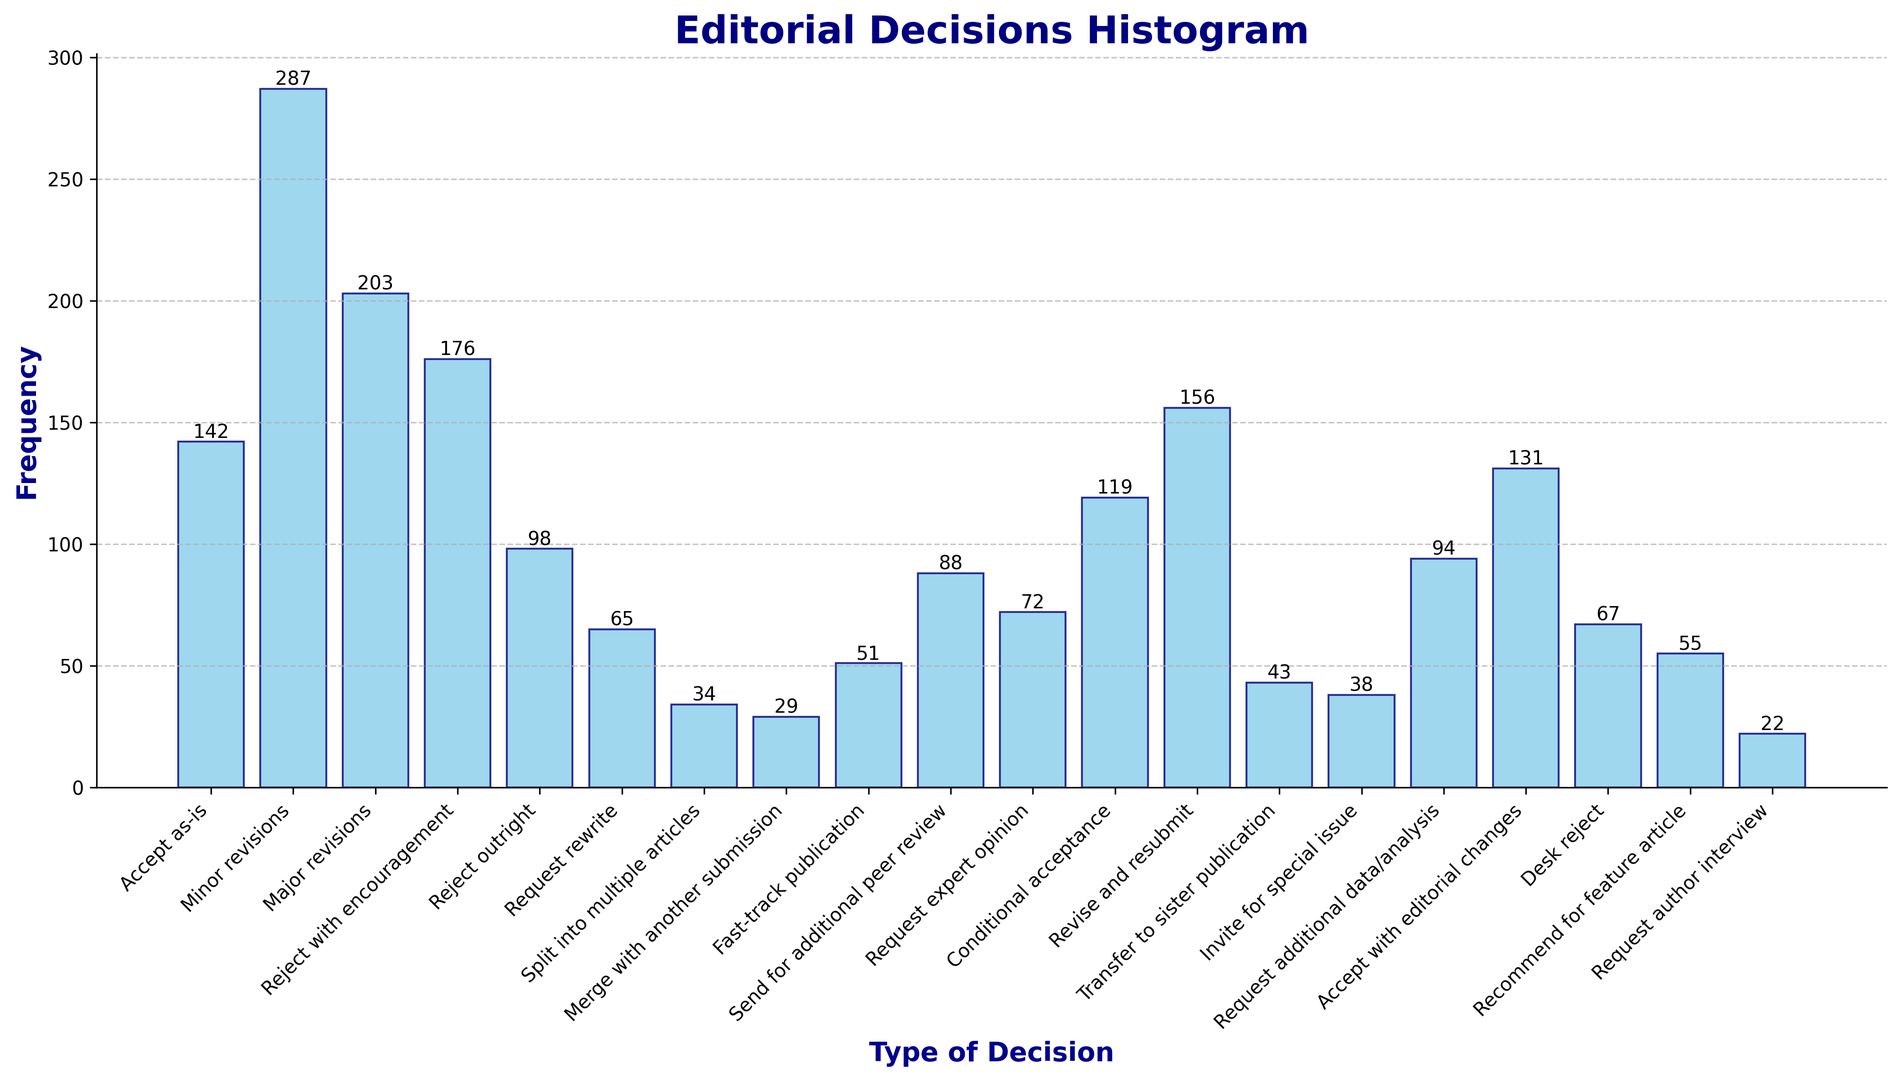What is the most frequent type of editorial decision? The histogram shows bars representing frequencies of each decision type. The tallest bar indicates the most frequent decision. The "Minor revisions" bar is the tallest.
Answer: Minor revisions How many total decisions resulted in either "Accept as-is" or "Desk reject"? Identify the frequencies for "Accept as-is" (142) and "Desk reject" (67), then sum them: 142 + 67 = 209.
Answer: 209 Which decision type has the smallest frequency? The histogram shows bars' heights corresponding to frequencies. The shortest bar represents the least frequent decision, which is "Request author interview" at 22.
Answer: Request author interview What is the combined frequency of all decisions requiring some form of "revise and resubmit"? Sum the frequencies of "Revise and resubmit" (156), "Major revisions" (203), and "Minor revisions" (287): 156 + 203 + 287 = 646.
Answer: 646 How many decisions are less frequent than "Request additional data/analysis"? Identify bars with frequencies lower than "Request additional data/analysis" (94): "Request author interview" (22), "Merge with another submission" (29), "Split into multiple articles" (34), "Invite for special issue" (38), "Transfer to sister publication" (43), "Fast-track publication" (51), "Recommend for feature article" (55), "Desk reject" (67), and "Request rewrite" (65). Count these decisions: 9.
Answer: 9 How many decisions had a frequency greater than "Reject outright"? Identify bars with frequencies higher than "Reject outright" (98): "Accept as-is" (142), "Minor revisions" (287), "Major revisions" (203), "Reject with encouragement" (176), "Revise and resubmit" (156), "Conditional acceptance" (119), and "Accept with editorial changes" (131). Count these decisions: 7.
Answer: 7 Which types of decisions have a frequency between 50 and 100? Identify bars with frequencies within the range 50 to 100: "Reject outright" (98), "Send for additional peer review" (88), "Request additional data/analysis" (94), "Fast-track publication" (51), and "Desk reject" (67).
Answer: Reject outright, Send for additional peer review, Request additional data/analysis, Fast-track publication, Desk reject What is the frequency difference between "Conditional acceptance" and "Reject outright"? The respective frequencies are "Conditional acceptance" (119) and "Reject outright" (98). Calculate the difference: 119 - 98 = 21.
Answer: 21 Which type of decision—"Transfer to sister publication" or "Invite for special issue"—is more frequent, and by how much? Compare the frequencies: "Transfer to sister publication" (43) and "Invite for special issue" (38). Calculate the difference: 43 - 38 = 5.
Answer: Transfer to sister publication by 5 